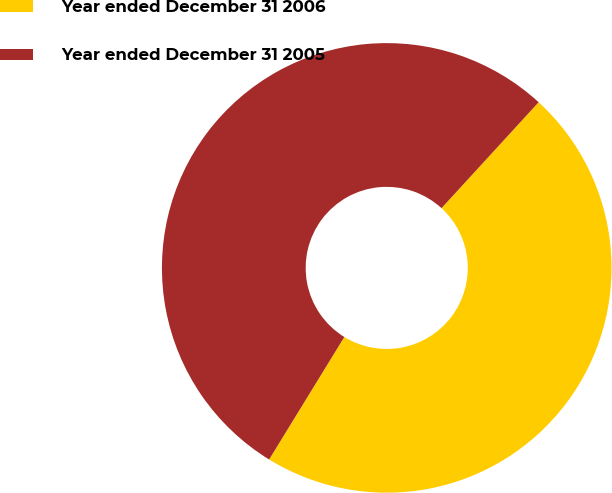<chart> <loc_0><loc_0><loc_500><loc_500><pie_chart><fcel>Year ended December 31 2006<fcel>Year ended December 31 2005<nl><fcel>46.95%<fcel>53.05%<nl></chart> 